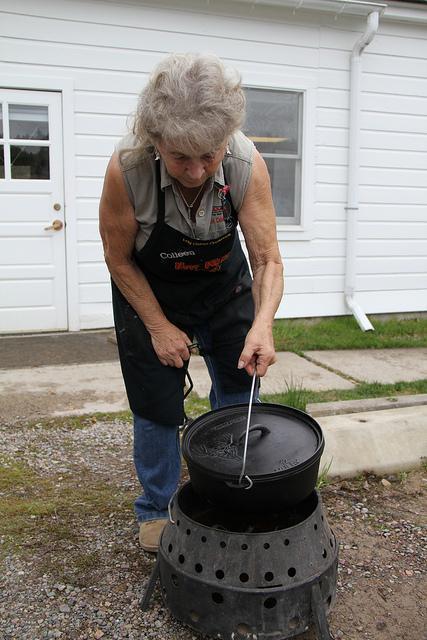How many levels doe the bus have?
Give a very brief answer. 0. 